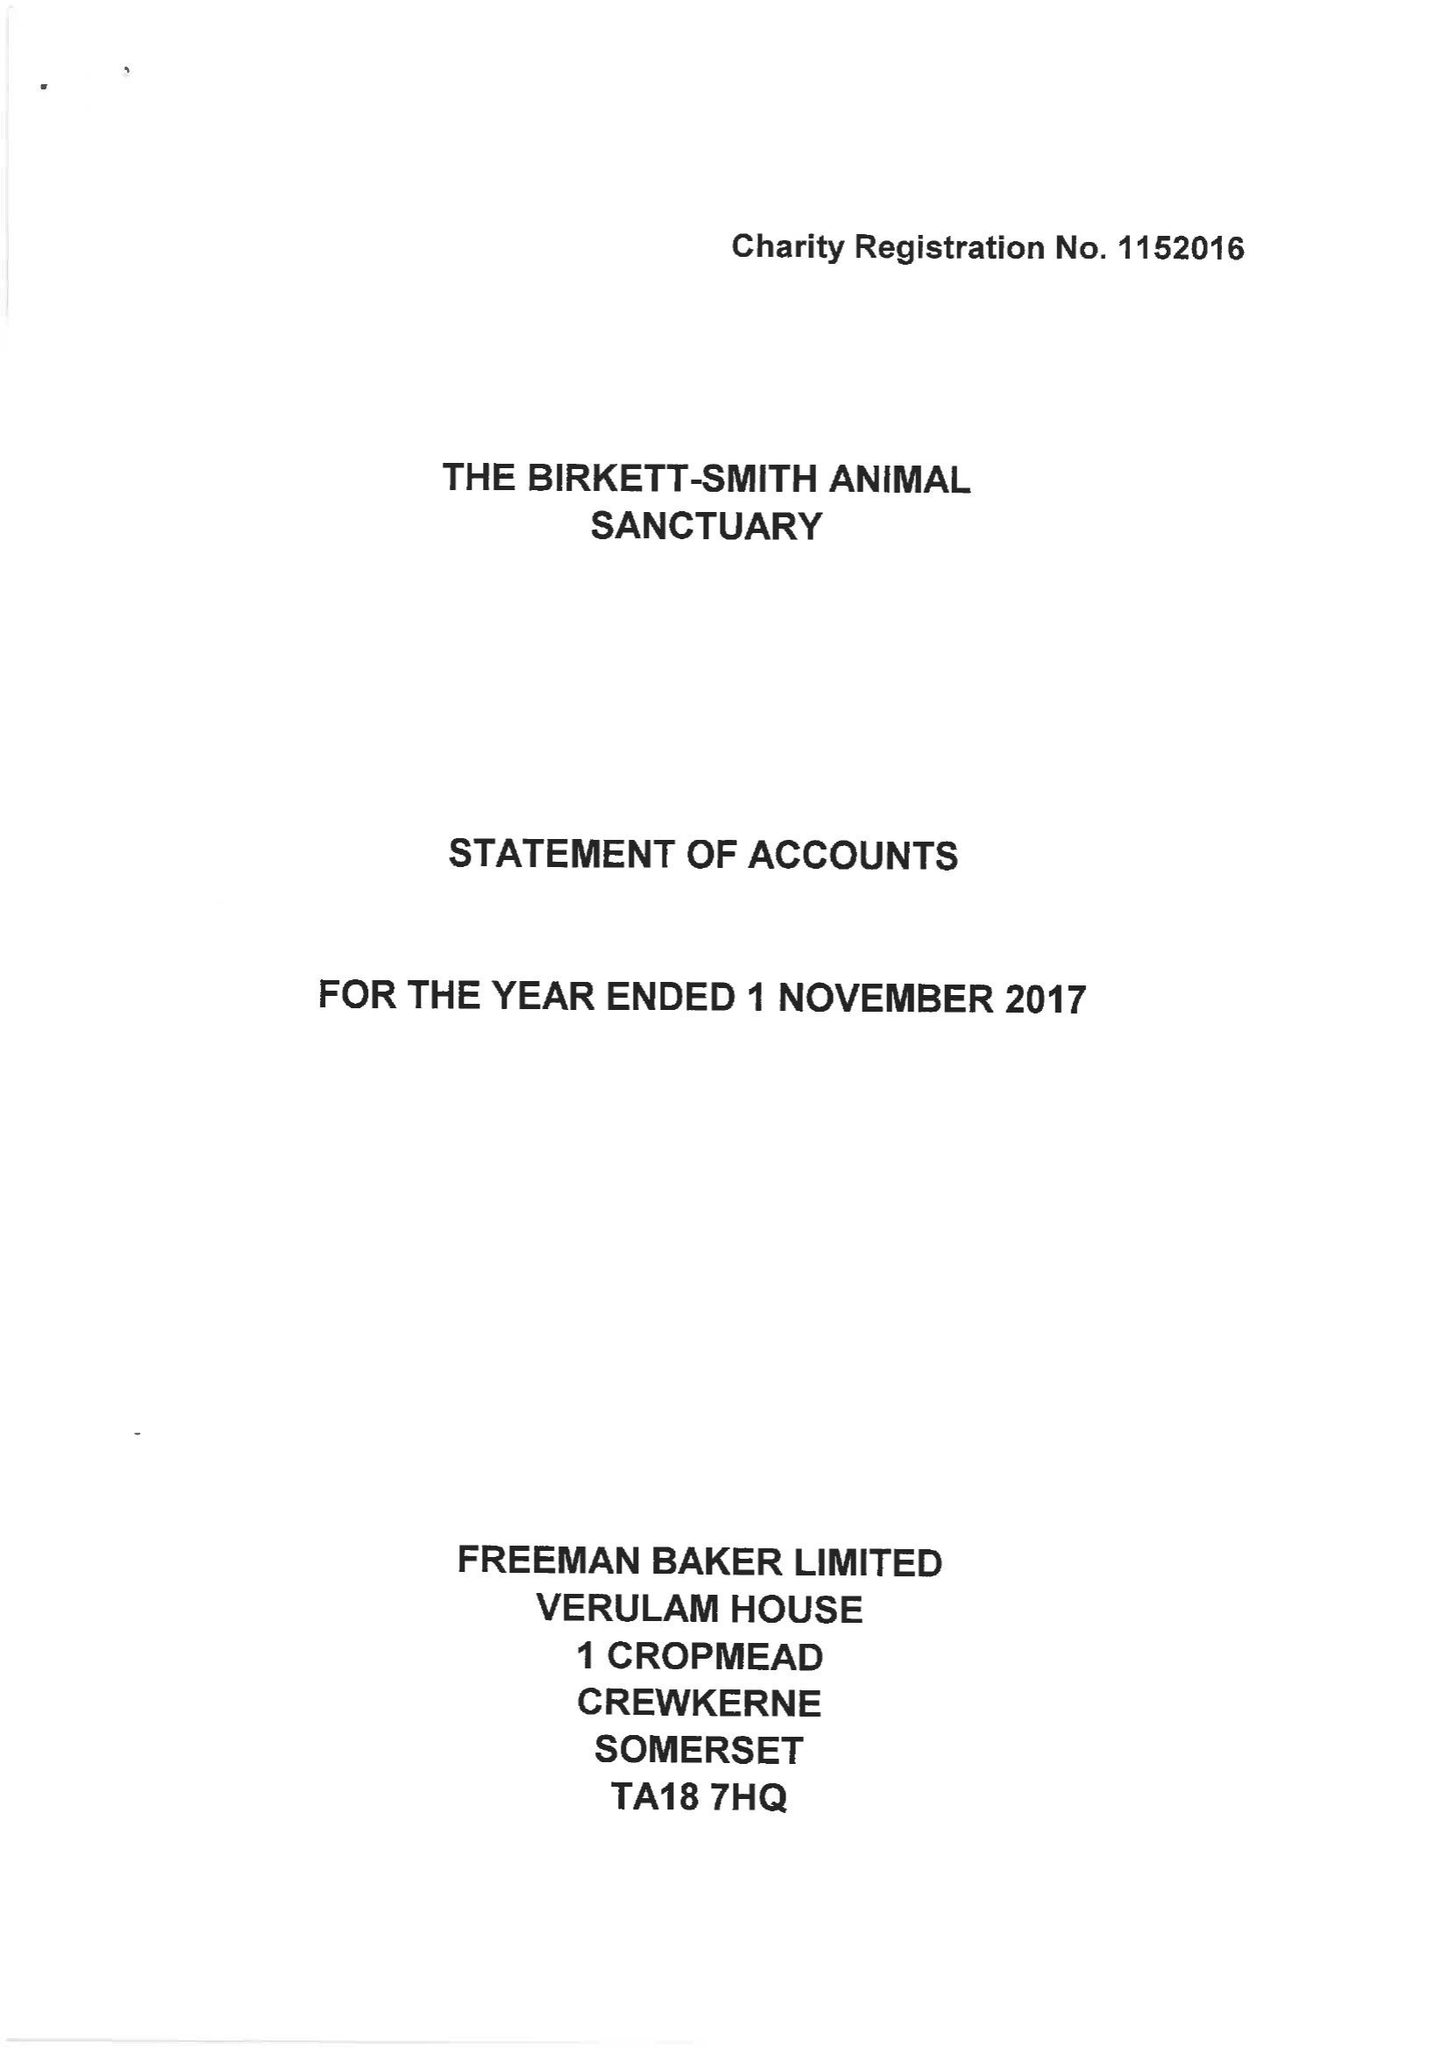What is the value for the spending_annually_in_british_pounds?
Answer the question using a single word or phrase. 121405.00 